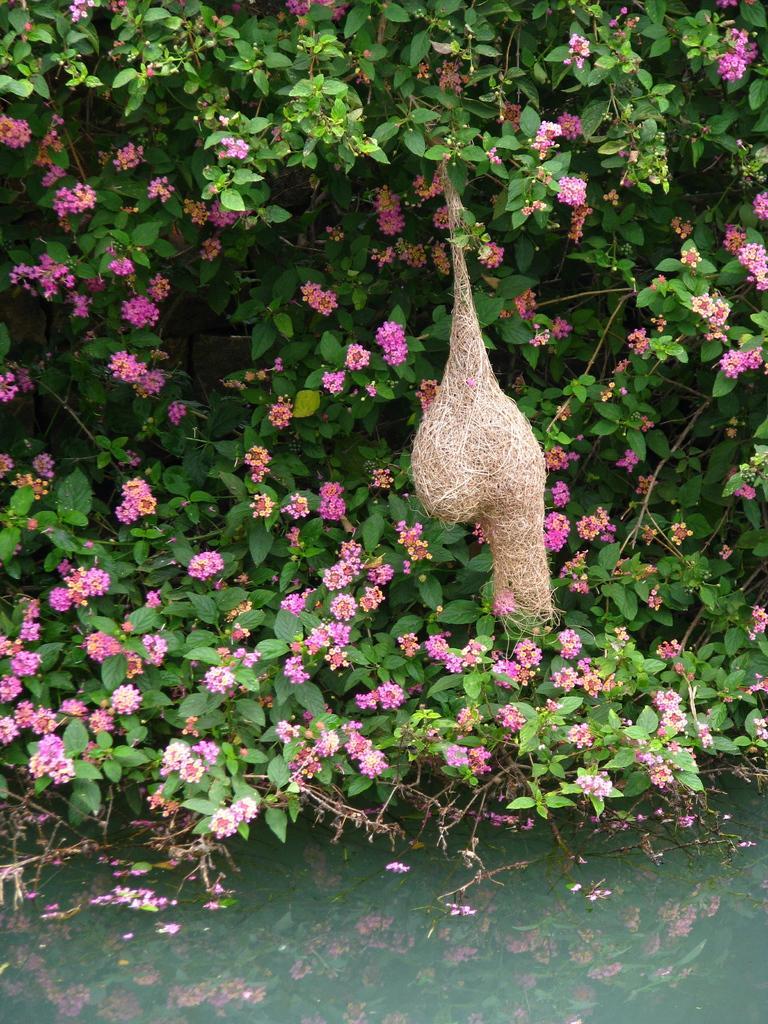In one or two sentences, can you explain what this image depicts? In this picture we can see some water, some flowers to the tree and also we can see bird nest to the trees. 